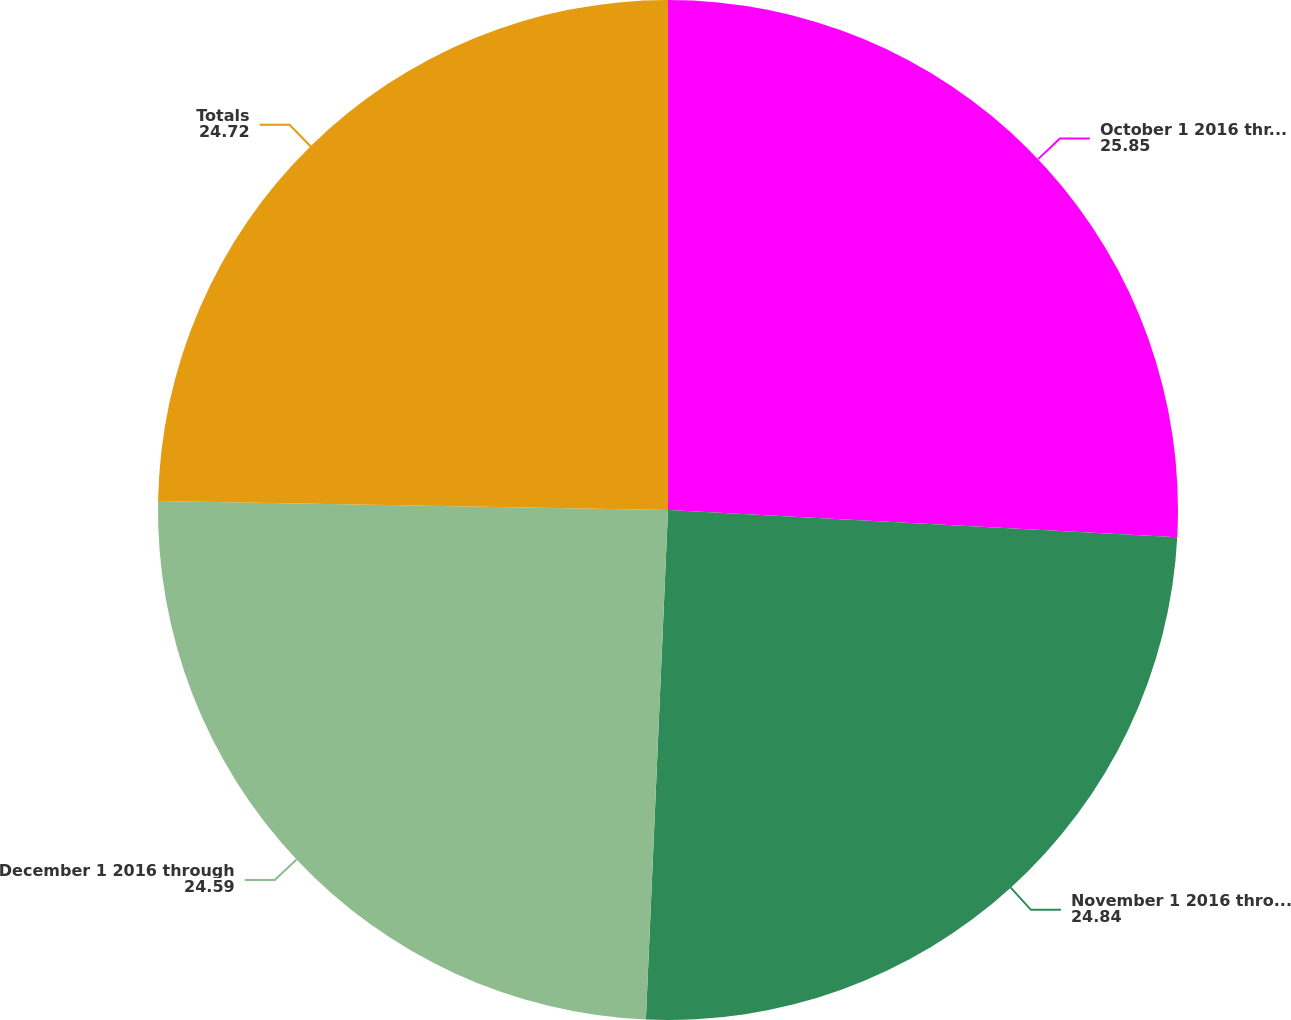Convert chart to OTSL. <chart><loc_0><loc_0><loc_500><loc_500><pie_chart><fcel>October 1 2016 through October<fcel>November 1 2016 through<fcel>December 1 2016 through<fcel>Totals<nl><fcel>25.85%<fcel>24.84%<fcel>24.59%<fcel>24.72%<nl></chart> 